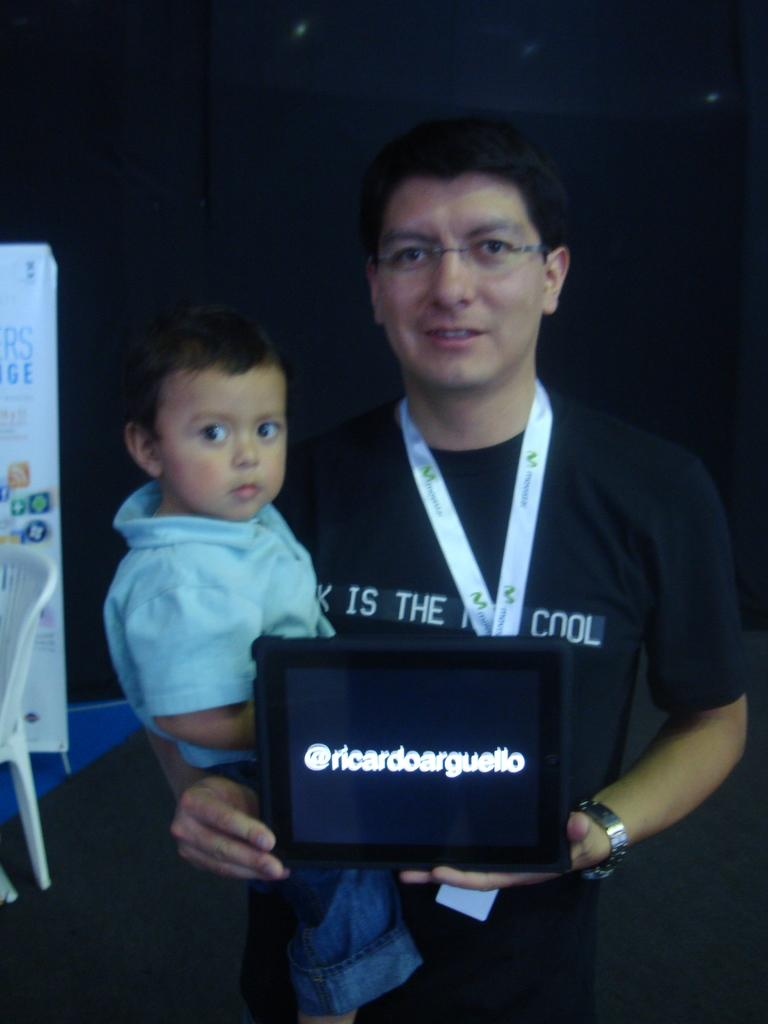Who is present in the image? There is a man and a kid in the image. What is the man doing in the image? The man is holding an object in the image. What type of furniture can be seen in the image? There is a chair in the image. What is visible in the background of the image? There is a hoarding in the image. What type of riddle is the man trying to solve in the image? There is no riddle present in the image; the man is simply holding an object. What authority figure can be seen in the image? There is no authority figure present in the image. 